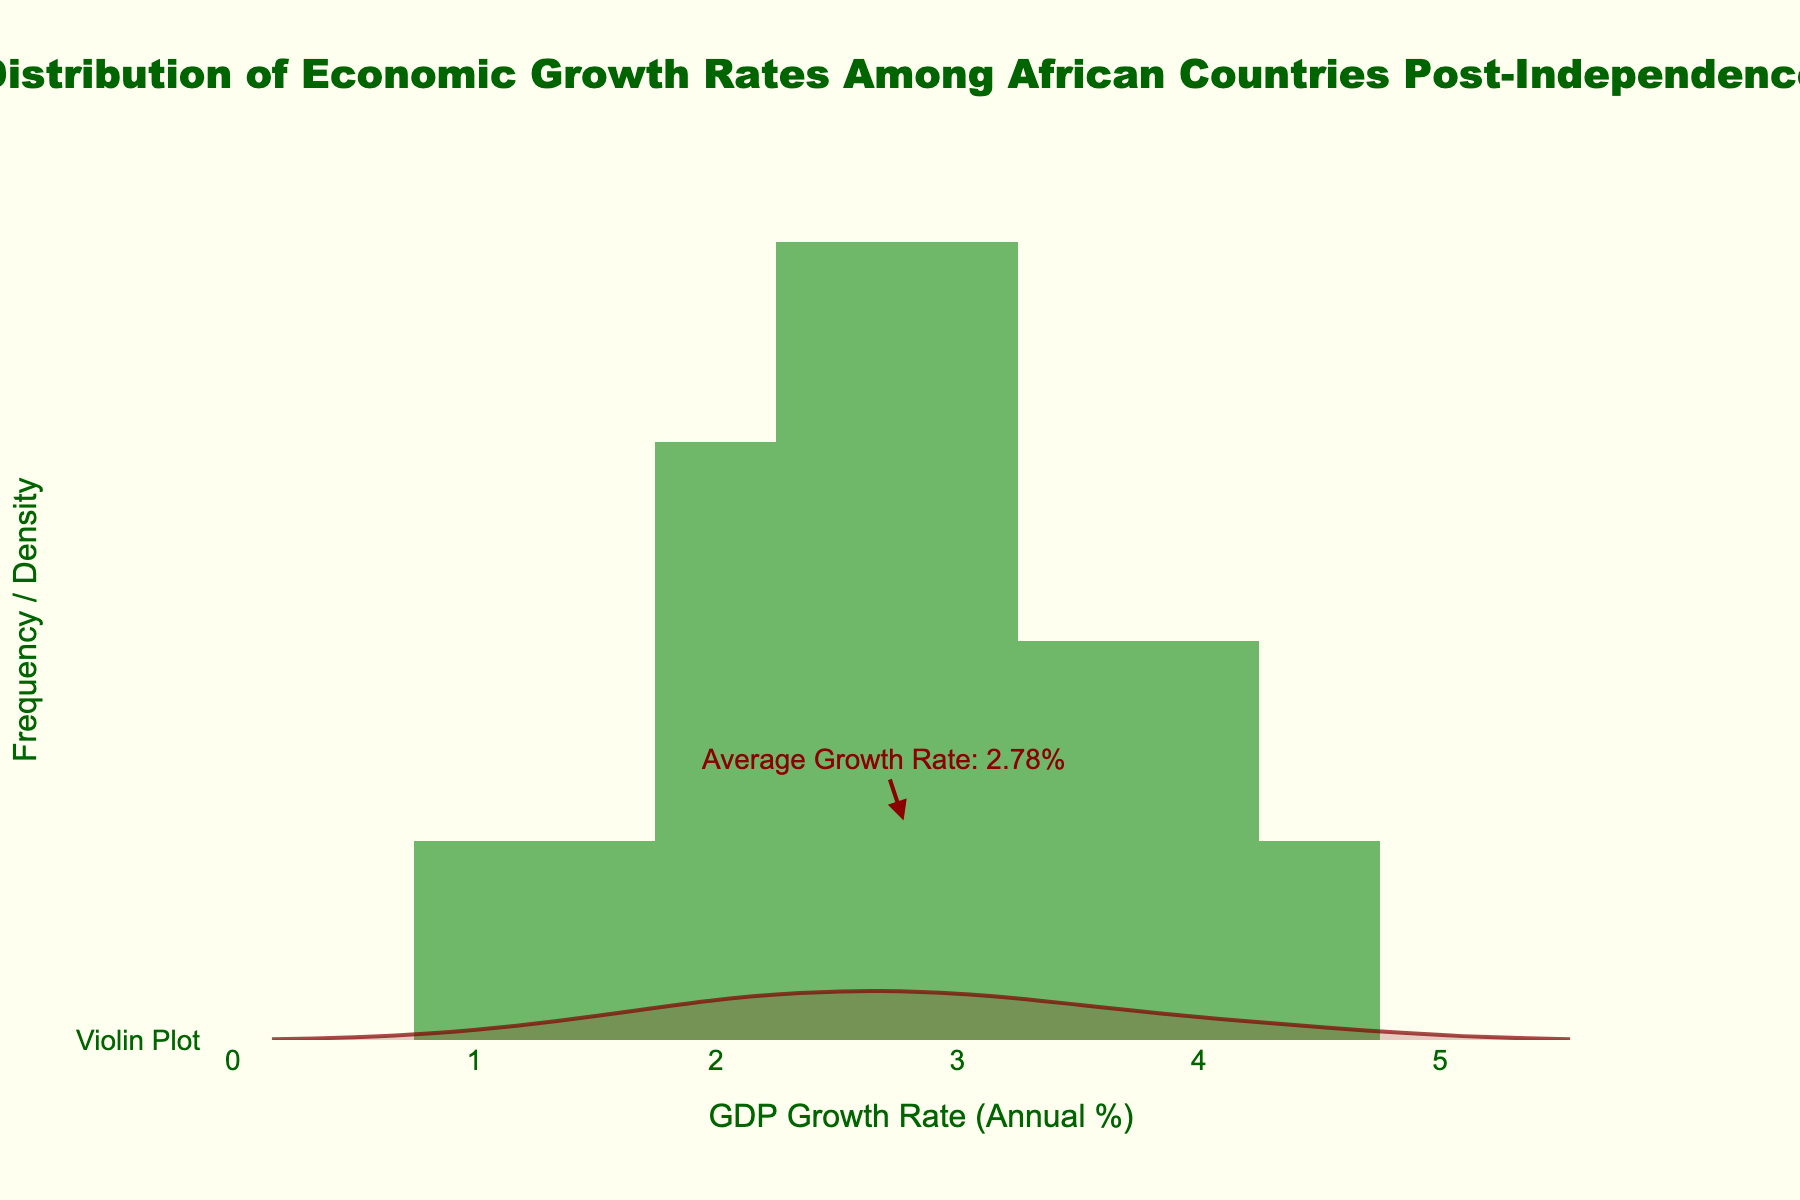Which country has the highest GDP growth rate? Observing the histogram and the annotated countries, it can be seen that Botswana has the highest GDP growth rate among the listed African countries.
Answer: Botswana What does the x-axis represent in the plot? The x-axis is labeled 'GDP Growth Rate (Annual %)', representing the annual percentage growth rate of GDP for each country.
Answer: GDP Growth Rate (Annual %) What is the title of the plot? The title is placed at the top center of the plot and reads 'Distribution of Economic Growth Rates Among African Countries Post-Independence'.
Answer: Distribution of Economic Growth Rates Among African Countries Post-Independence Which GDP growth rate range has the highest frequency? The highest bar of the histogram indicates the range with the highest frequency. This bar is around the 2.5% to 3.0% GDP growth rate range.
Answer: 2.5% to 3.0% What color is used for the histogram bars? The histogram bars are colored in a shade of green, as indicated by observing the bar's color and the legend.
Answer: Green What is the average GDP growth rate across all the countries? The average GDP growth rate is marked by an annotation near the x-axis. The annotation shows the average growth rate to be approximately 2.89%.
Answer: 2.89% Is the GDP growth rate of Ghana above or below the average growth rate? Ghana's GDP growth rate is 4.1%, which is visually above the annotated average growth rate of 2.89%.
Answer: Above How many countries have a GDP growth rate higher than the average? Observing the histogram and checking the bars' height to the right of the average annotation, there are 8 countries with a growth rate higher than the average.
Answer: 8 What does the violin plot represent in this figure? The violin plot overlays the histogram, providing a visual representation of the distribution density. The density is shown with a red outline and lightly filled area, indicating where values concentrate.
Answer: Distribution density 